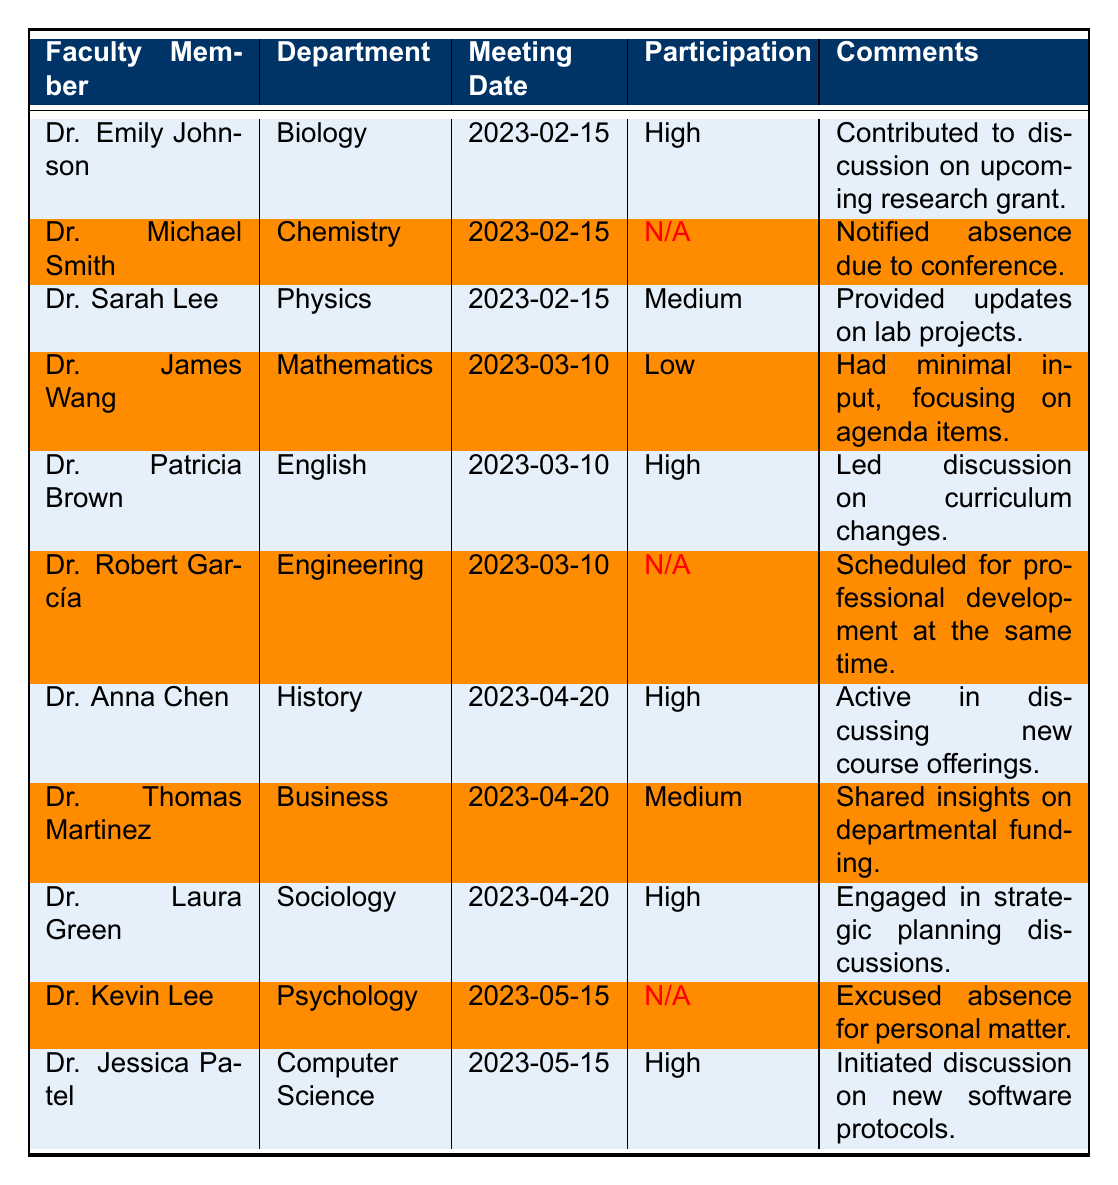What is the attendance status of Dr. Emily Johnson? In the table, Dr. Emily Johnson's attendance status is listed as "Present" for the meeting on 2023-02-15.
Answer: Present How many faculty members participated in the meeting on 2023-03-10? In the table, there are three faculty members listed for the meeting on 2023-03-10: Dr. James Wang, Dr. Patricia Brown, and Dr. Robert García. Both Dr. James Wang and Dr. Patricia Brown were present, while Dr. Robert García was absent. Thus, 2 faculty members participated.
Answer: 2 What were the comments made by Dr. Jessica Patel? For Dr. Jessica Patel, the table has the comment: "Initiated discussion on new software protocols."
Answer: Initiated discussion on new software protocols Which department had a member with high participation in the meeting on 2023-04-20? In the table, both Dr. Anna Chen (History) and Dr. Laura Green (Sociology) had high participation on 2023-04-20.
Answer: History and Sociology Did Dr. Michael Smith participate in the faculty meeting on 2023-02-15? The table indicates that Dr. Michael Smith was absent for the meeting on 2023-02-15, therefore he did not participate.
Answer: No What is the participation level of Dr. Kevin Lee? Dr. Kevin Lee's participation level is listed as "N/A" in the table since he was absent from the meeting on 2023-05-15.
Answer: N/A How many faculty members had a high participation level overall? Reviewing the table, Dr. Emily Johnson, Dr. Patricia Brown, Dr. Anna Chen, Dr. Laura Green, and Dr. Jessica Patel all had a high participation level. Adding them together, there are five faculty members with high participation.
Answer: 5 Was there any faculty member who participated with a low participation level? In the table, Dr. James Wang is noted to have a low participation level in the meeting on 2023-03-10.
Answer: Yes What comments did Dr. Sarah Lee provide during her participation? The comments for Dr. Sarah Lee state she "Provided updates on lab projects." This is the only comment associated with her in the table.
Answer: Provided updates on lab projects Count the total number of absent faculty members across all meetings listed. The table shows that Dr. Michael Smith, Dr. Robert García, and Dr. Kevin Lee were absent. This makes a total of three absentees across the meetings.
Answer: 3 